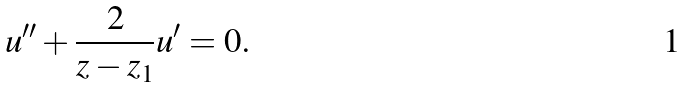<formula> <loc_0><loc_0><loc_500><loc_500>u ^ { \prime \prime } + \frac { 2 } { z - z _ { 1 } } u ^ { \prime } = 0 .</formula> 